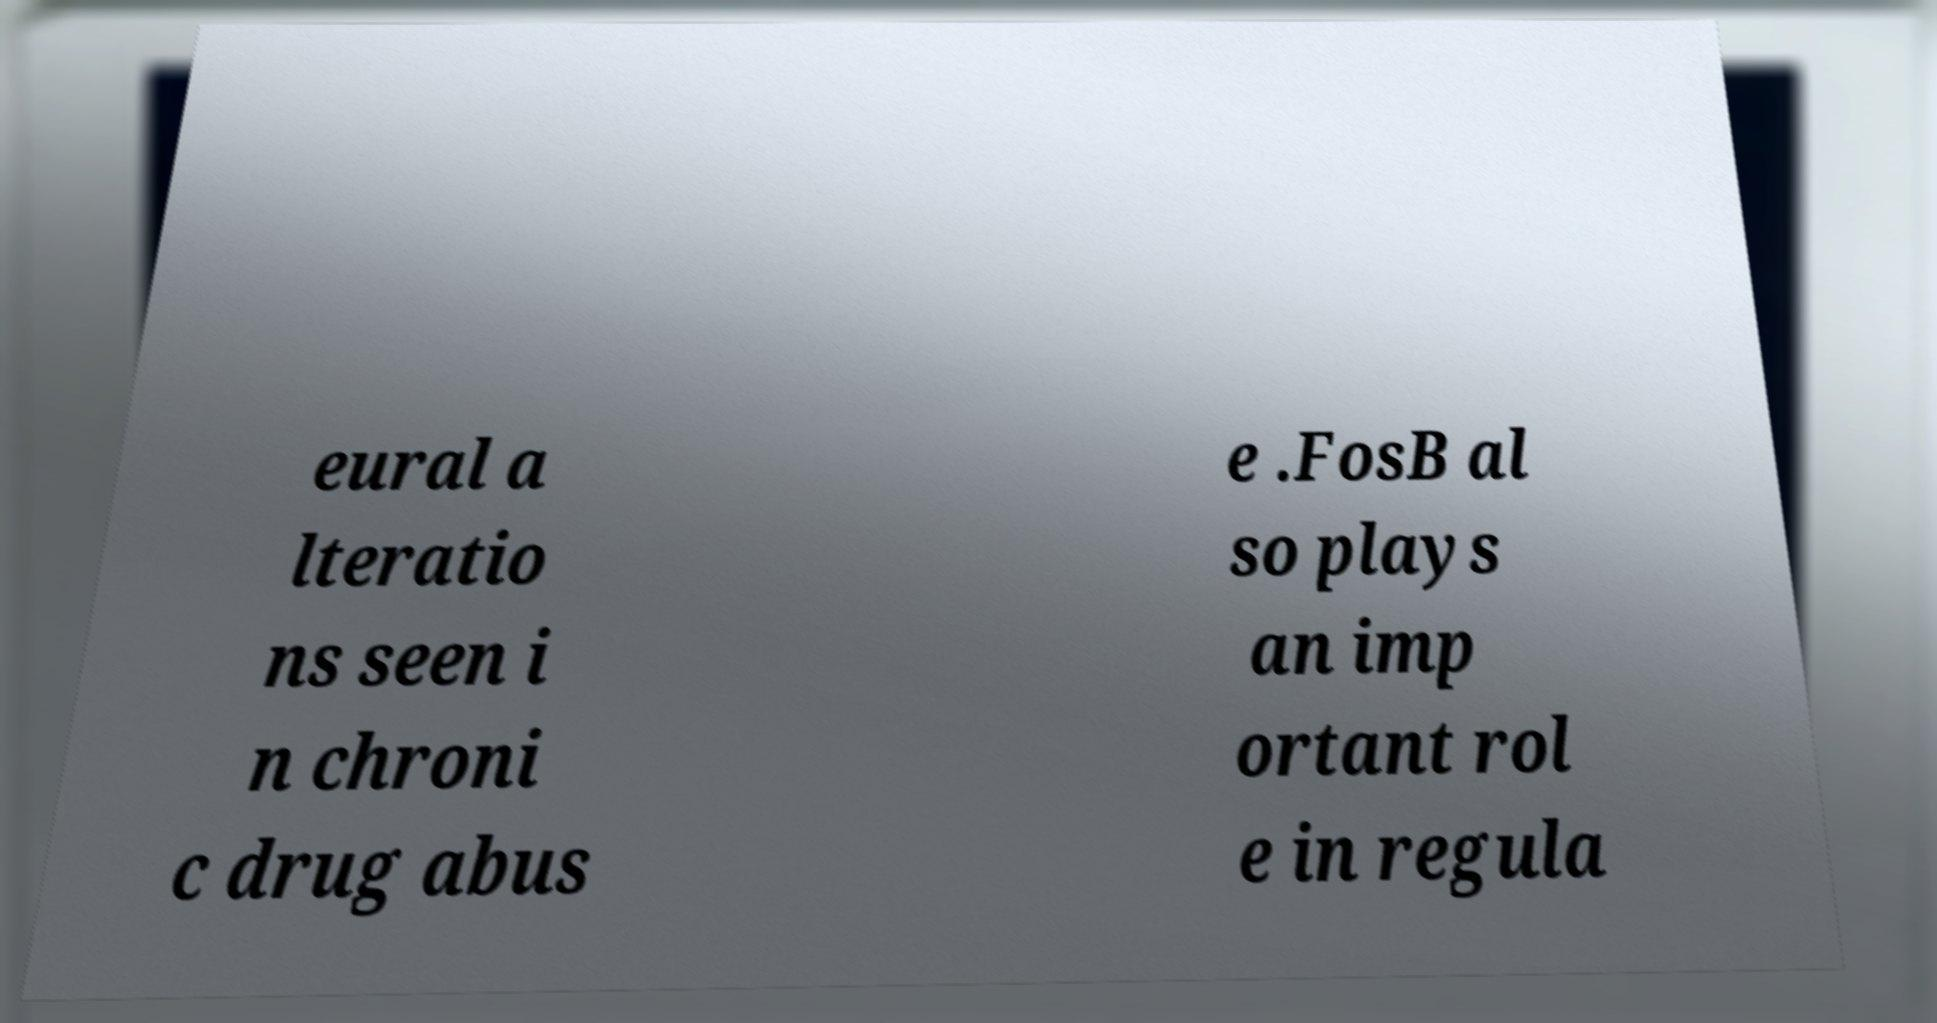Please read and relay the text visible in this image. What does it say? eural a lteratio ns seen i n chroni c drug abus e .FosB al so plays an imp ortant rol e in regula 